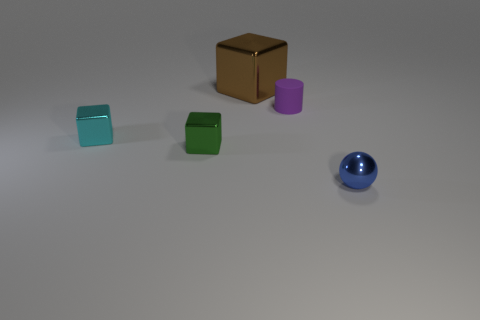Is there a green cube made of the same material as the small ball?
Your answer should be very brief. Yes. Are there fewer large brown metallic things in front of the tiny purple rubber cylinder than small cyan rubber blocks?
Your answer should be compact. No. There is a block that is left of the small metal cube that is in front of the tiny cyan shiny block; what is its material?
Your answer should be compact. Metal. The thing that is behind the cyan metal object and on the left side of the tiny purple cylinder has what shape?
Make the answer very short. Cube. How many other things are there of the same color as the rubber cylinder?
Your answer should be compact. 0. How many things are either tiny objects behind the small blue ball or cyan metallic things?
Offer a very short reply. 3. There is a tiny shiny sphere; is it the same color as the small shiny cube in front of the cyan thing?
Keep it short and to the point. No. Is there any other thing that has the same size as the shiny sphere?
Provide a short and direct response. Yes. There is a metallic thing that is to the right of the metallic thing that is behind the small rubber thing; how big is it?
Give a very brief answer. Small. How many things are either tiny blue metal balls or small shiny things on the left side of the purple matte cylinder?
Make the answer very short. 3. 